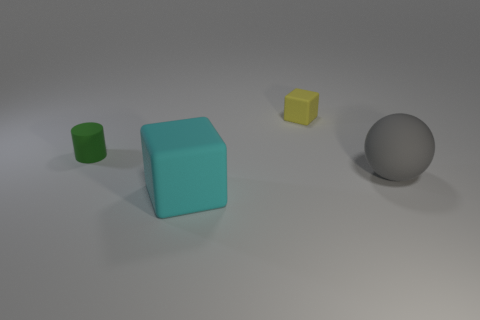There is a thing behind the small green cylinder; what is its shape? The object behind the small green cylinder is a gray sphere. Spheres are characterized by having a uniform shape from all angles, and this one has a smooth texture that can reflect a bit of light, which is noticeable even in this image. 